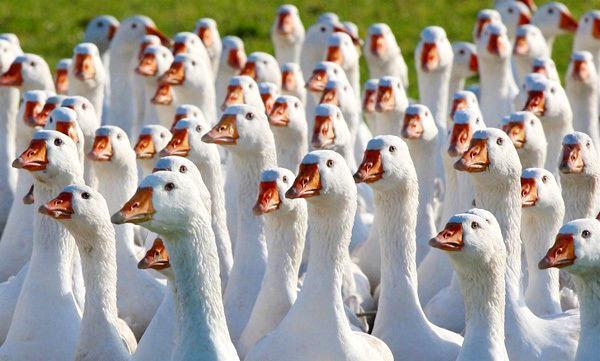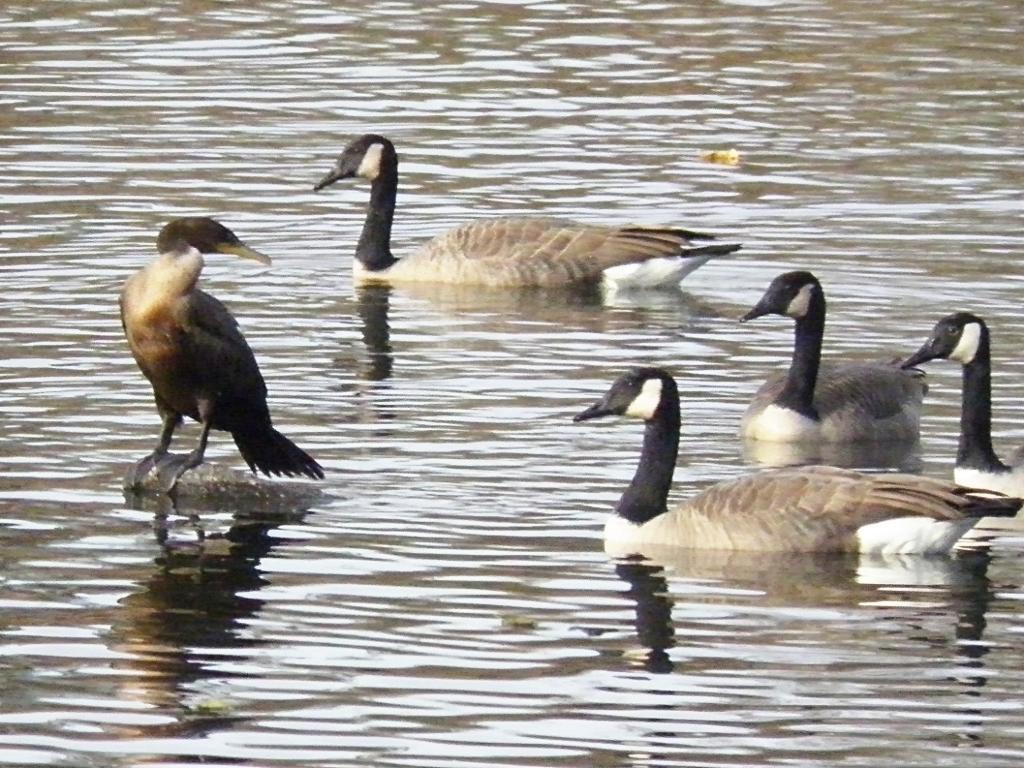The first image is the image on the left, the second image is the image on the right. Given the left and right images, does the statement "At least one of the birds is in a watery area." hold true? Answer yes or no. Yes. The first image is the image on the left, the second image is the image on the right. Examine the images to the left and right. Is the description "There are two adult black and brown geese visible" accurate? Answer yes or no. No. 